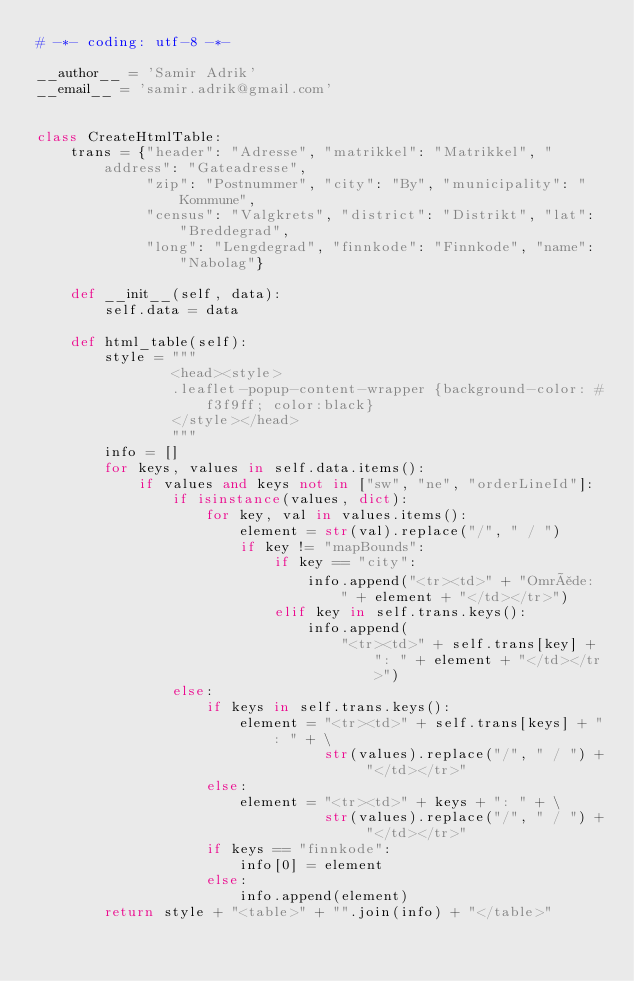<code> <loc_0><loc_0><loc_500><loc_500><_Python_># -*- coding: utf-8 -*-

__author__ = 'Samir Adrik'
__email__ = 'samir.adrik@gmail.com'


class CreateHtmlTable:
    trans = {"header": "Adresse", "matrikkel": "Matrikkel", "address": "Gateadresse",
             "zip": "Postnummer", "city": "By", "municipality": "Kommune",
             "census": "Valgkrets", "district": "Distrikt", "lat": "Breddegrad",
             "long": "Lengdegrad", "finnkode": "Finnkode", "name": "Nabolag"}

    def __init__(self, data):
        self.data = data

    def html_table(self):
        style = """
                <head><style>
                .leaflet-popup-content-wrapper {background-color: #f3f9ff; color:black}
                </style></head>
                """
        info = []
        for keys, values in self.data.items():
            if values and keys not in ["sw", "ne", "orderLineId"]:
                if isinstance(values, dict):
                    for key, val in values.items():
                        element = str(val).replace("/", " / ")
                        if key != "mapBounds":
                            if key == "city":
                                info.append("<tr><td>" + "Område: " + element + "</td></tr>")
                            elif key in self.trans.keys():
                                info.append(
                                    "<tr><td>" + self.trans[key] + ": " + element + "</td></tr>")
                else:
                    if keys in self.trans.keys():
                        element = "<tr><td>" + self.trans[keys] + ": " + \
                                  str(values).replace("/", " / ") + "</td></tr>"
                    else:
                        element = "<tr><td>" + keys + ": " + \
                                  str(values).replace("/", " / ") + "</td></tr>"
                    if keys == "finnkode":
                        info[0] = element
                    else:
                        info.append(element)
        return style + "<table>" + "".join(info) + "</table>"
</code> 